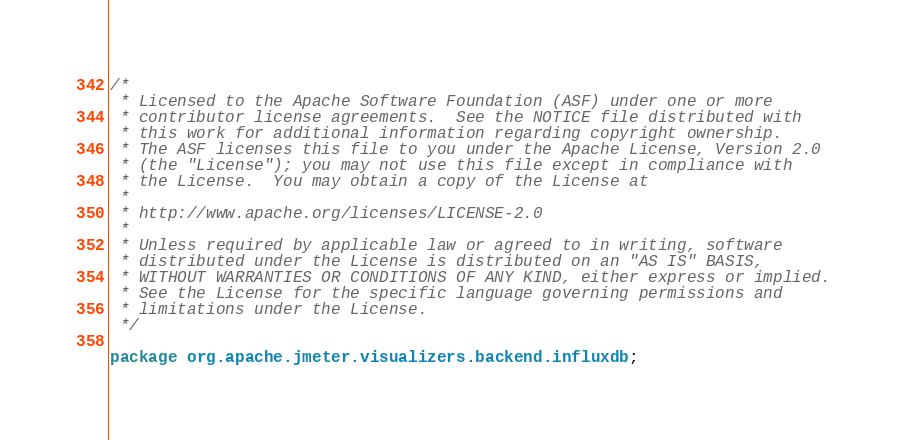<code> <loc_0><loc_0><loc_500><loc_500><_Java_>/*
 * Licensed to the Apache Software Foundation (ASF) under one or more
 * contributor license agreements.  See the NOTICE file distributed with
 * this work for additional information regarding copyright ownership.
 * The ASF licenses this file to you under the Apache License, Version 2.0
 * (the "License"); you may not use this file except in compliance with
 * the License.  You may obtain a copy of the License at
 *
 * http://www.apache.org/licenses/LICENSE-2.0
 *
 * Unless required by applicable law or agreed to in writing, software
 * distributed under the License is distributed on an "AS IS" BASIS,
 * WITHOUT WARRANTIES OR CONDITIONS OF ANY KIND, either express or implied.
 * See the License for the specific language governing permissions and
 * limitations under the License.
 */

package org.apache.jmeter.visualizers.backend.influxdb;
</code> 